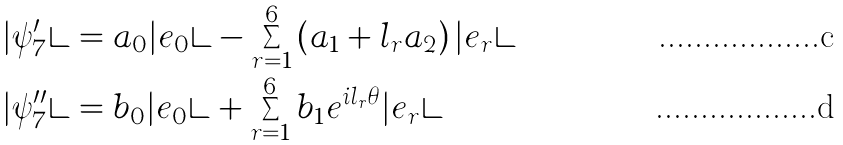<formula> <loc_0><loc_0><loc_500><loc_500>| \psi ^ { \prime } _ { 7 } \rangle & = a _ { 0 } | e _ { 0 } \rangle - \sum _ { r = 1 } ^ { 6 } \left ( a _ { 1 } + l _ { r } a _ { 2 } \right ) | e _ { r } \rangle \\ | \psi ^ { \prime \prime } _ { 7 } \rangle & = b _ { 0 } | e _ { 0 } \rangle + \sum _ { r = 1 } ^ { 6 } b _ { 1 } e ^ { i l _ { r } \theta } | e _ { r } \rangle</formula> 